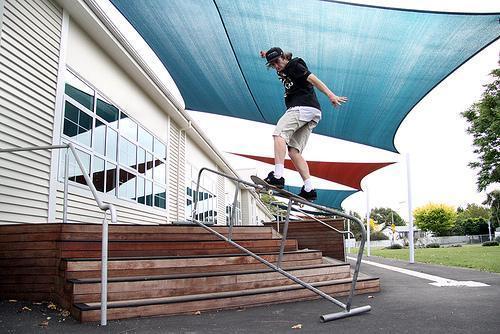How many people are there?
Give a very brief answer. 1. How many steps are there?
Give a very brief answer. 5. How many cups on the table are wine glasses?
Give a very brief answer. 0. 